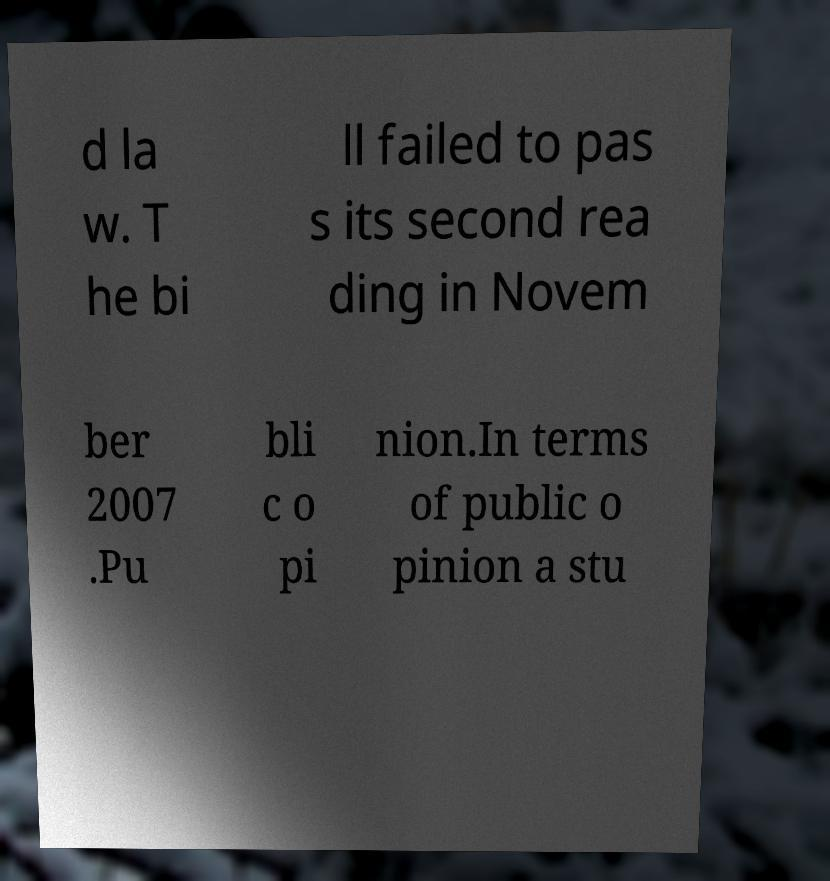Can you accurately transcribe the text from the provided image for me? d la w. T he bi ll failed to pas s its second rea ding in Novem ber 2007 .Pu bli c o pi nion.In terms of public o pinion a stu 